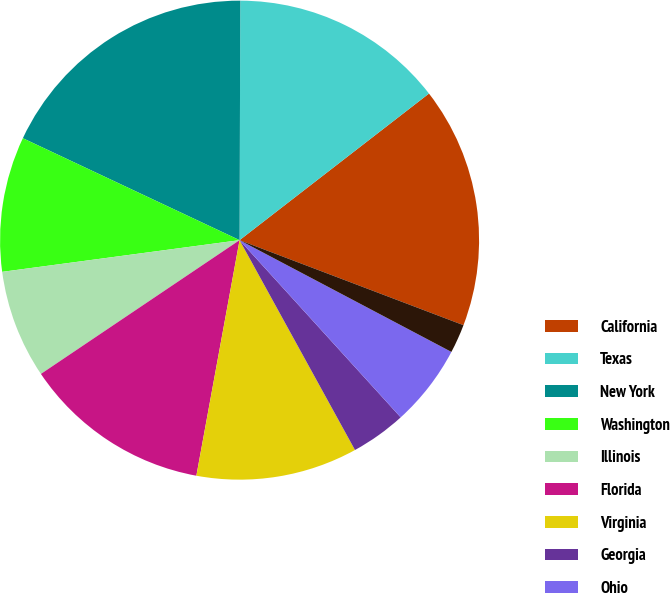<chart> <loc_0><loc_0><loc_500><loc_500><pie_chart><fcel>California<fcel>Texas<fcel>New York<fcel>Washington<fcel>Illinois<fcel>Florida<fcel>Virginia<fcel>Georgia<fcel>Ohio<fcel>Wisconsin<nl><fcel>16.26%<fcel>14.47%<fcel>18.05%<fcel>9.11%<fcel>7.32%<fcel>12.68%<fcel>10.89%<fcel>3.74%<fcel>5.53%<fcel>1.95%<nl></chart> 